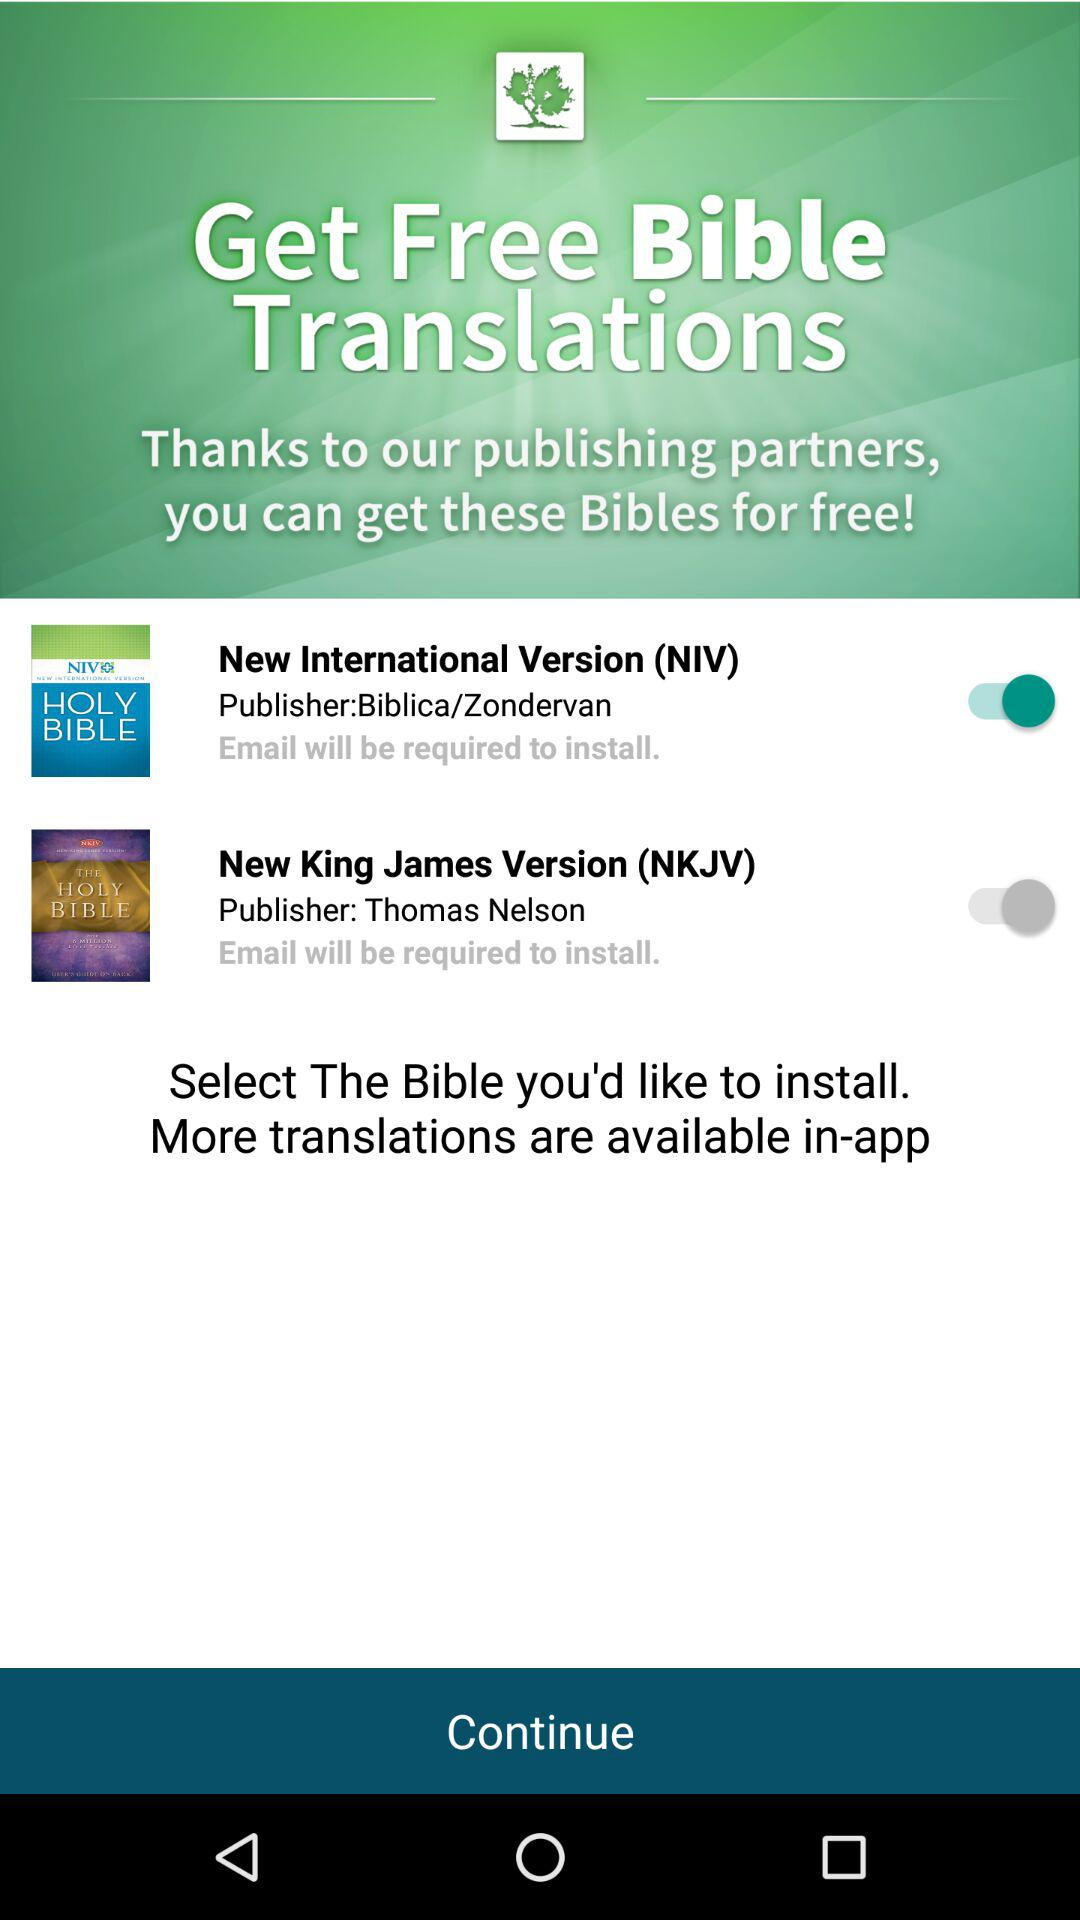What's the status of "New International Version (NIV)"? The status of "New International Version (NIV)" is "on". 